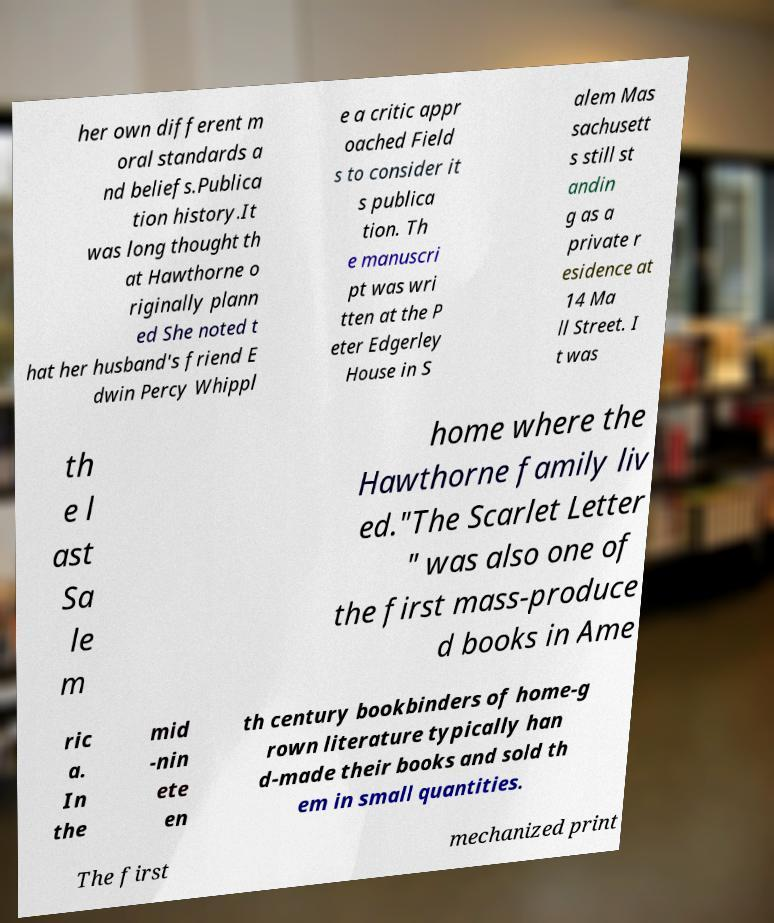There's text embedded in this image that I need extracted. Can you transcribe it verbatim? her own different m oral standards a nd beliefs.Publica tion history.It was long thought th at Hawthorne o riginally plann ed She noted t hat her husband's friend E dwin Percy Whippl e a critic appr oached Field s to consider it s publica tion. Th e manuscri pt was wri tten at the P eter Edgerley House in S alem Mas sachusett s still st andin g as a private r esidence at 14 Ma ll Street. I t was th e l ast Sa le m home where the Hawthorne family liv ed."The Scarlet Letter " was also one of the first mass-produce d books in Ame ric a. In the mid -nin ete en th century bookbinders of home-g rown literature typically han d-made their books and sold th em in small quantities. The first mechanized print 